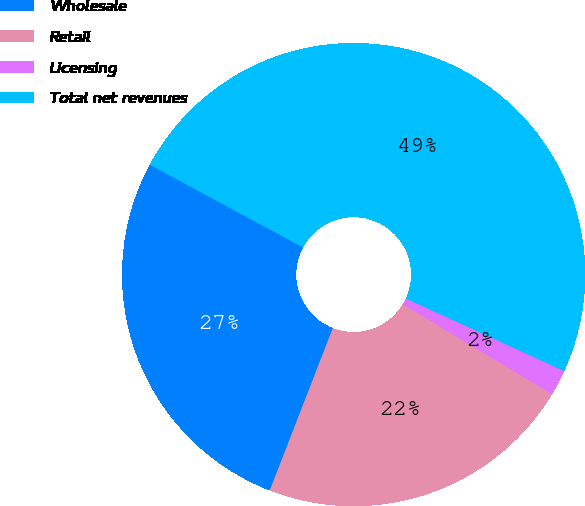<chart> <loc_0><loc_0><loc_500><loc_500><pie_chart><fcel>Wholesale<fcel>Retail<fcel>Licensing<fcel>Total net revenues<nl><fcel>26.97%<fcel>22.26%<fcel>1.8%<fcel>48.97%<nl></chart> 